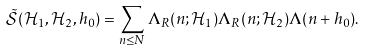Convert formula to latex. <formula><loc_0><loc_0><loc_500><loc_500>\tilde { \mathcal { S } } ( \mathcal { H } _ { 1 } , \mathcal { H } _ { 2 } , h _ { 0 } ) = \sum _ { n \leq N } \Lambda _ { R } ( n ; \mathcal { H } _ { 1 } ) \Lambda _ { R } ( n ; \mathcal { H } _ { 2 } ) \Lambda ( n + h _ { 0 } ) .</formula> 